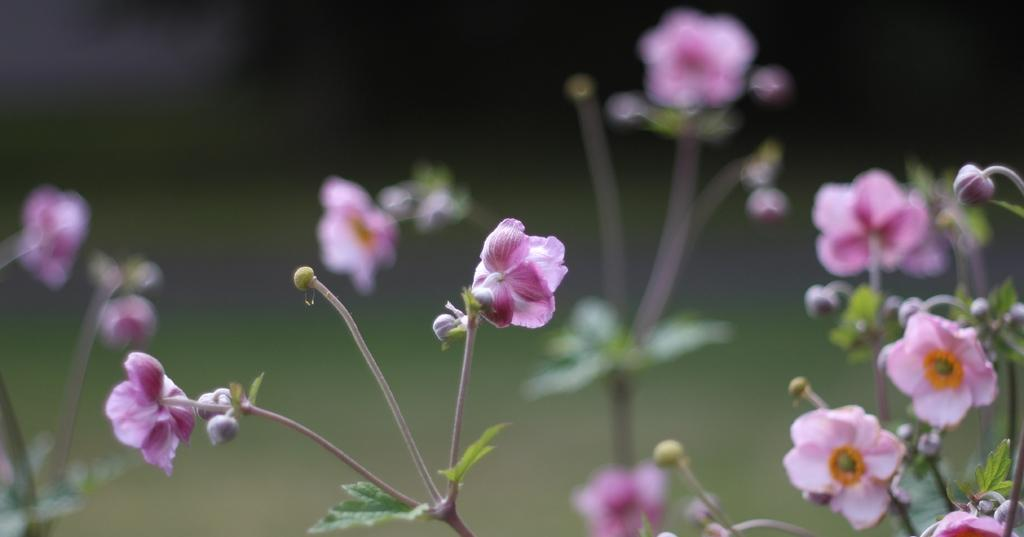What type of flowers can be seen on the plant in the image? There are pink flowers on a plant in the image. Can you describe the background of the image? The background of the image is blurry. What card did your grandmother receive last month in the image? There is no card or mention of a grandmother in the image; it only features pink flowers on a plant and a blurry background. 